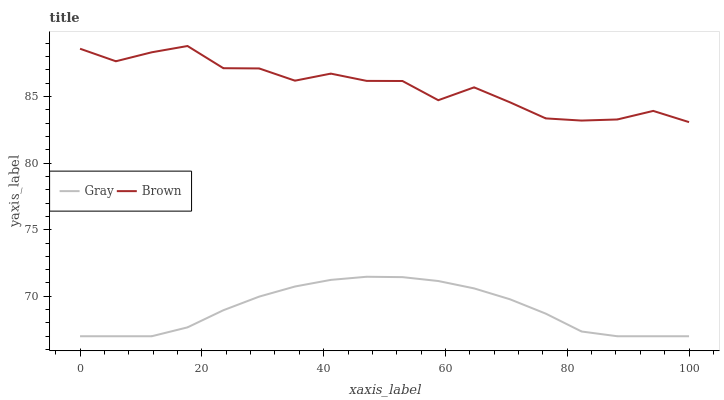Does Gray have the minimum area under the curve?
Answer yes or no. Yes. Does Brown have the maximum area under the curve?
Answer yes or no. Yes. Does Brown have the minimum area under the curve?
Answer yes or no. No. Is Gray the smoothest?
Answer yes or no. Yes. Is Brown the roughest?
Answer yes or no. Yes. Is Brown the smoothest?
Answer yes or no. No. Does Brown have the lowest value?
Answer yes or no. No. Does Brown have the highest value?
Answer yes or no. Yes. Is Gray less than Brown?
Answer yes or no. Yes. Is Brown greater than Gray?
Answer yes or no. Yes. Does Gray intersect Brown?
Answer yes or no. No. 